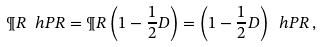<formula> <loc_0><loc_0><loc_500><loc_500>\P R \ h P R = \P R \left ( 1 - \frac { 1 } { 2 } D \right ) = \left ( 1 - \frac { 1 } { 2 } D \right ) \ h P R \, ,</formula> 